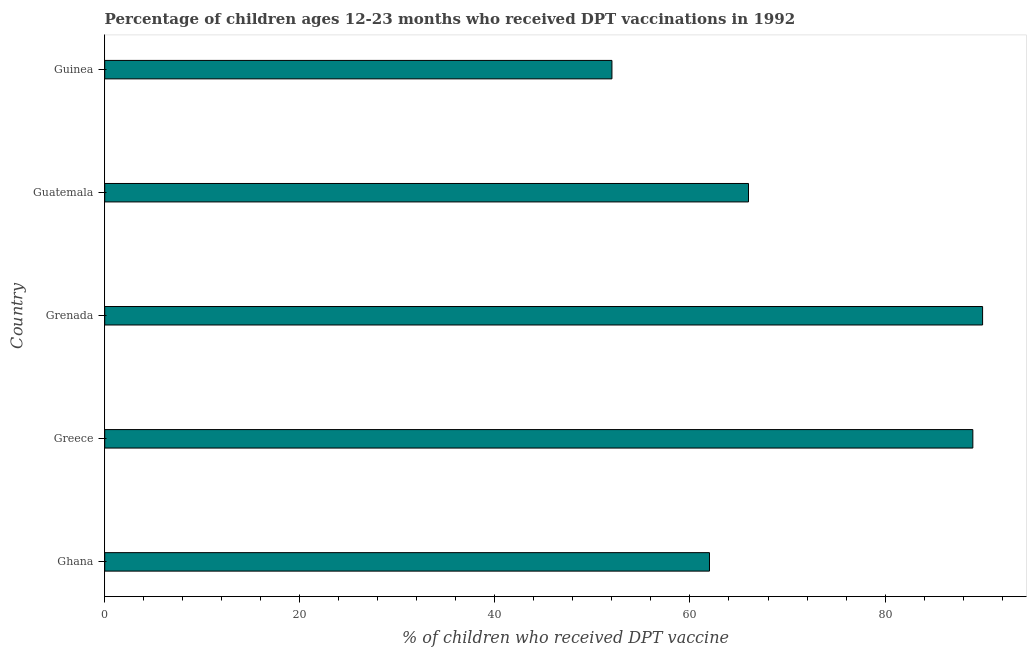Does the graph contain any zero values?
Your answer should be compact. No. Does the graph contain grids?
Ensure brevity in your answer.  No. What is the title of the graph?
Keep it short and to the point. Percentage of children ages 12-23 months who received DPT vaccinations in 1992. What is the label or title of the X-axis?
Ensure brevity in your answer.  % of children who received DPT vaccine. What is the label or title of the Y-axis?
Keep it short and to the point. Country. What is the percentage of children who received dpt vaccine in Grenada?
Ensure brevity in your answer.  90. Across all countries, what is the minimum percentage of children who received dpt vaccine?
Your response must be concise. 52. In which country was the percentage of children who received dpt vaccine maximum?
Offer a very short reply. Grenada. In which country was the percentage of children who received dpt vaccine minimum?
Provide a succinct answer. Guinea. What is the sum of the percentage of children who received dpt vaccine?
Provide a succinct answer. 359. What is the difference between the percentage of children who received dpt vaccine in Grenada and Guatemala?
Provide a short and direct response. 24. What is the average percentage of children who received dpt vaccine per country?
Your answer should be very brief. 71.8. What is the ratio of the percentage of children who received dpt vaccine in Greece to that in Guinea?
Provide a succinct answer. 1.71. Is the difference between the percentage of children who received dpt vaccine in Greece and Grenada greater than the difference between any two countries?
Give a very brief answer. No. What is the difference between the highest and the second highest percentage of children who received dpt vaccine?
Provide a succinct answer. 1. How many bars are there?
Your answer should be very brief. 5. How many countries are there in the graph?
Provide a succinct answer. 5. Are the values on the major ticks of X-axis written in scientific E-notation?
Make the answer very short. No. What is the % of children who received DPT vaccine of Ghana?
Your answer should be very brief. 62. What is the % of children who received DPT vaccine of Greece?
Provide a succinct answer. 89. What is the % of children who received DPT vaccine of Guatemala?
Provide a short and direct response. 66. What is the % of children who received DPT vaccine in Guinea?
Keep it short and to the point. 52. What is the difference between the % of children who received DPT vaccine in Ghana and Grenada?
Provide a short and direct response. -28. What is the difference between the % of children who received DPT vaccine in Ghana and Guinea?
Offer a very short reply. 10. What is the difference between the % of children who received DPT vaccine in Greece and Guinea?
Keep it short and to the point. 37. What is the difference between the % of children who received DPT vaccine in Grenada and Guatemala?
Give a very brief answer. 24. What is the difference between the % of children who received DPT vaccine in Grenada and Guinea?
Give a very brief answer. 38. What is the ratio of the % of children who received DPT vaccine in Ghana to that in Greece?
Make the answer very short. 0.7. What is the ratio of the % of children who received DPT vaccine in Ghana to that in Grenada?
Keep it short and to the point. 0.69. What is the ratio of the % of children who received DPT vaccine in Ghana to that in Guatemala?
Offer a very short reply. 0.94. What is the ratio of the % of children who received DPT vaccine in Ghana to that in Guinea?
Offer a very short reply. 1.19. What is the ratio of the % of children who received DPT vaccine in Greece to that in Grenada?
Ensure brevity in your answer.  0.99. What is the ratio of the % of children who received DPT vaccine in Greece to that in Guatemala?
Your answer should be compact. 1.35. What is the ratio of the % of children who received DPT vaccine in Greece to that in Guinea?
Make the answer very short. 1.71. What is the ratio of the % of children who received DPT vaccine in Grenada to that in Guatemala?
Your answer should be compact. 1.36. What is the ratio of the % of children who received DPT vaccine in Grenada to that in Guinea?
Your response must be concise. 1.73. What is the ratio of the % of children who received DPT vaccine in Guatemala to that in Guinea?
Offer a very short reply. 1.27. 